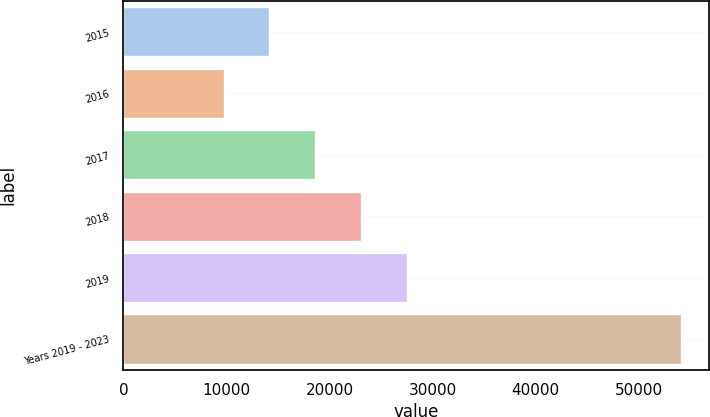Convert chart. <chart><loc_0><loc_0><loc_500><loc_500><bar_chart><fcel>2015<fcel>2016<fcel>2017<fcel>2018<fcel>2019<fcel>Years 2019 - 2023<nl><fcel>14152.5<fcel>9713<fcel>18592<fcel>23031.5<fcel>27471<fcel>54108<nl></chart> 